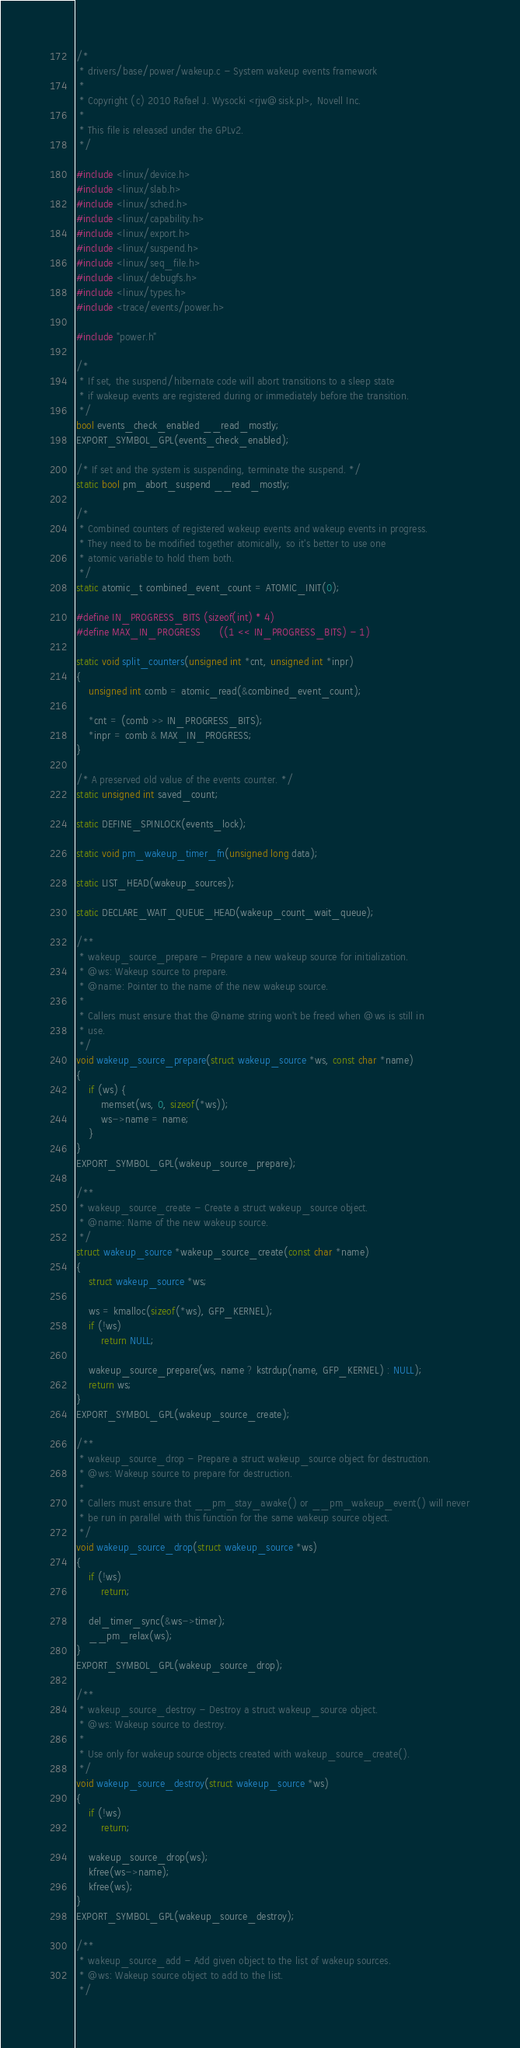<code> <loc_0><loc_0><loc_500><loc_500><_C_>/*
 * drivers/base/power/wakeup.c - System wakeup events framework
 *
 * Copyright (c) 2010 Rafael J. Wysocki <rjw@sisk.pl>, Novell Inc.
 *
 * This file is released under the GPLv2.
 */

#include <linux/device.h>
#include <linux/slab.h>
#include <linux/sched.h>
#include <linux/capability.h>
#include <linux/export.h>
#include <linux/suspend.h>
#include <linux/seq_file.h>
#include <linux/debugfs.h>
#include <linux/types.h>
#include <trace/events/power.h>

#include "power.h"

/*
 * If set, the suspend/hibernate code will abort transitions to a sleep state
 * if wakeup events are registered during or immediately before the transition.
 */
bool events_check_enabled __read_mostly;
EXPORT_SYMBOL_GPL(events_check_enabled);

/* If set and the system is suspending, terminate the suspend. */
static bool pm_abort_suspend __read_mostly;

/*
 * Combined counters of registered wakeup events and wakeup events in progress.
 * They need to be modified together atomically, so it's better to use one
 * atomic variable to hold them both.
 */
static atomic_t combined_event_count = ATOMIC_INIT(0);

#define IN_PROGRESS_BITS	(sizeof(int) * 4)
#define MAX_IN_PROGRESS		((1 << IN_PROGRESS_BITS) - 1)

static void split_counters(unsigned int *cnt, unsigned int *inpr)
{
	unsigned int comb = atomic_read(&combined_event_count);

	*cnt = (comb >> IN_PROGRESS_BITS);
	*inpr = comb & MAX_IN_PROGRESS;
}

/* A preserved old value of the events counter. */
static unsigned int saved_count;

static DEFINE_SPINLOCK(events_lock);

static void pm_wakeup_timer_fn(unsigned long data);

static LIST_HEAD(wakeup_sources);

static DECLARE_WAIT_QUEUE_HEAD(wakeup_count_wait_queue);

/**
 * wakeup_source_prepare - Prepare a new wakeup source for initialization.
 * @ws: Wakeup source to prepare.
 * @name: Pointer to the name of the new wakeup source.
 *
 * Callers must ensure that the @name string won't be freed when @ws is still in
 * use.
 */
void wakeup_source_prepare(struct wakeup_source *ws, const char *name)
{
	if (ws) {
		memset(ws, 0, sizeof(*ws));
		ws->name = name;
	}
}
EXPORT_SYMBOL_GPL(wakeup_source_prepare);

/**
 * wakeup_source_create - Create a struct wakeup_source object.
 * @name: Name of the new wakeup source.
 */
struct wakeup_source *wakeup_source_create(const char *name)
{
	struct wakeup_source *ws;

	ws = kmalloc(sizeof(*ws), GFP_KERNEL);
	if (!ws)
		return NULL;

	wakeup_source_prepare(ws, name ? kstrdup(name, GFP_KERNEL) : NULL);
	return ws;
}
EXPORT_SYMBOL_GPL(wakeup_source_create);

/**
 * wakeup_source_drop - Prepare a struct wakeup_source object for destruction.
 * @ws: Wakeup source to prepare for destruction.
 *
 * Callers must ensure that __pm_stay_awake() or __pm_wakeup_event() will never
 * be run in parallel with this function for the same wakeup source object.
 */
void wakeup_source_drop(struct wakeup_source *ws)
{
	if (!ws)
		return;

	del_timer_sync(&ws->timer);
	__pm_relax(ws);
}
EXPORT_SYMBOL_GPL(wakeup_source_drop);

/**
 * wakeup_source_destroy - Destroy a struct wakeup_source object.
 * @ws: Wakeup source to destroy.
 *
 * Use only for wakeup source objects created with wakeup_source_create().
 */
void wakeup_source_destroy(struct wakeup_source *ws)
{
	if (!ws)
		return;

	wakeup_source_drop(ws);
	kfree(ws->name);
	kfree(ws);
}
EXPORT_SYMBOL_GPL(wakeup_source_destroy);

/**
 * wakeup_source_add - Add given object to the list of wakeup sources.
 * @ws: Wakeup source object to add to the list.
 */</code> 